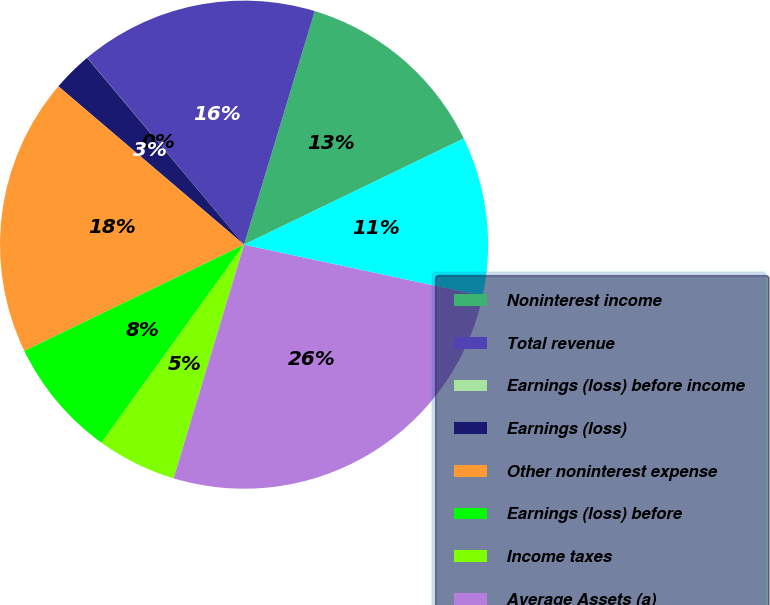<chart> <loc_0><loc_0><loc_500><loc_500><pie_chart><fcel>Noninterest income<fcel>Total revenue<fcel>Earnings (loss) before income<fcel>Earnings (loss)<fcel>Other noninterest expense<fcel>Earnings (loss) before<fcel>Income taxes<fcel>Average Assets (a)<fcel>Earnings before minority<nl><fcel>13.16%<fcel>15.79%<fcel>0.01%<fcel>2.64%<fcel>18.41%<fcel>7.9%<fcel>5.27%<fcel>26.3%<fcel>10.53%<nl></chart> 